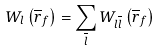<formula> <loc_0><loc_0><loc_500><loc_500>W _ { l } \left ( \overline { r } _ { f } \right ) = \sum _ { \overline { l } } W _ { l \overline { l } } \left ( \overline { r } _ { f } \right )</formula> 